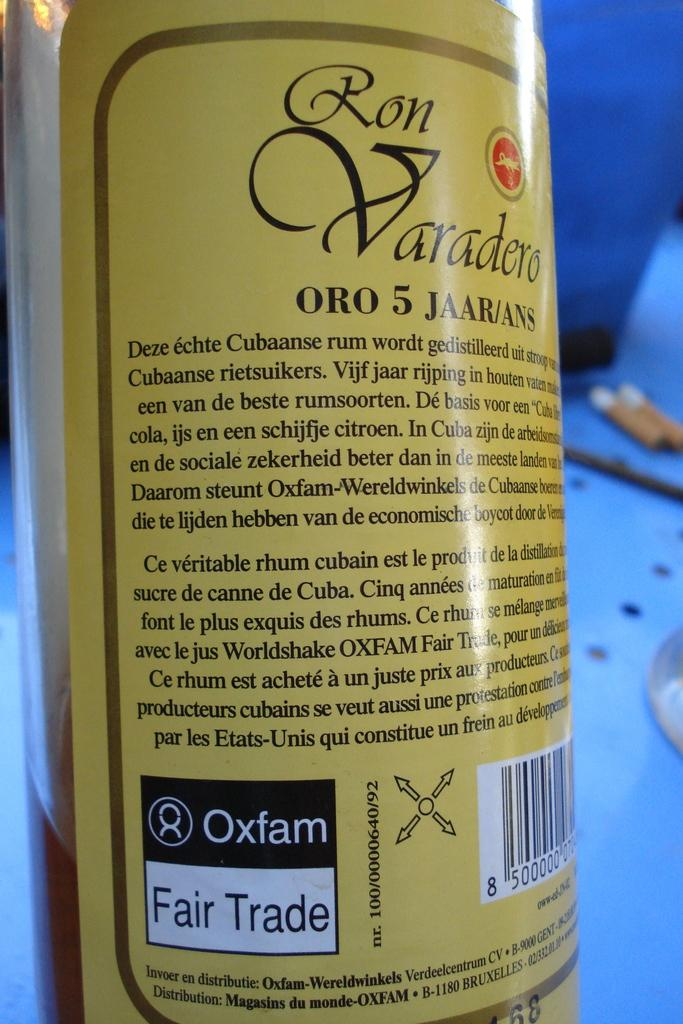<image>
Write a terse but informative summary of the picture. the number 5 is on the back of a bottle 